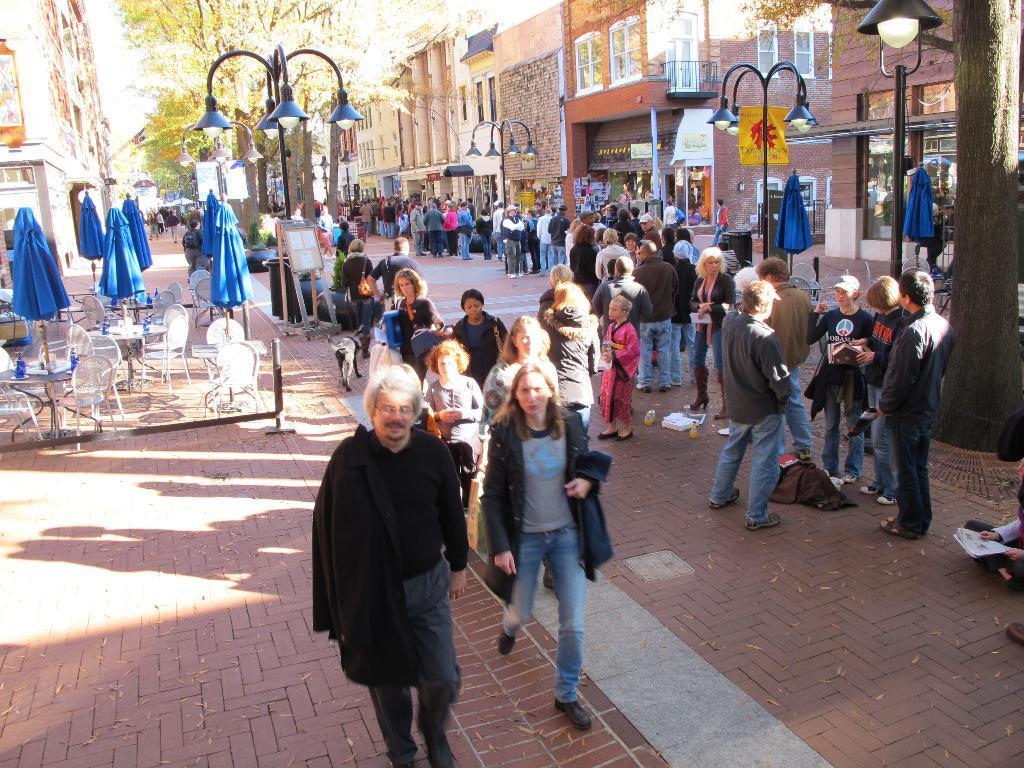Describe this image in one or two sentences. There is a crowd standing in the middle of this image and there are some buildings in the background. There are some chairs, tables, umbrellas and trees on the left side of this image. There is a tree on the right side of this image, and there is a floor at the bottom of this image. 